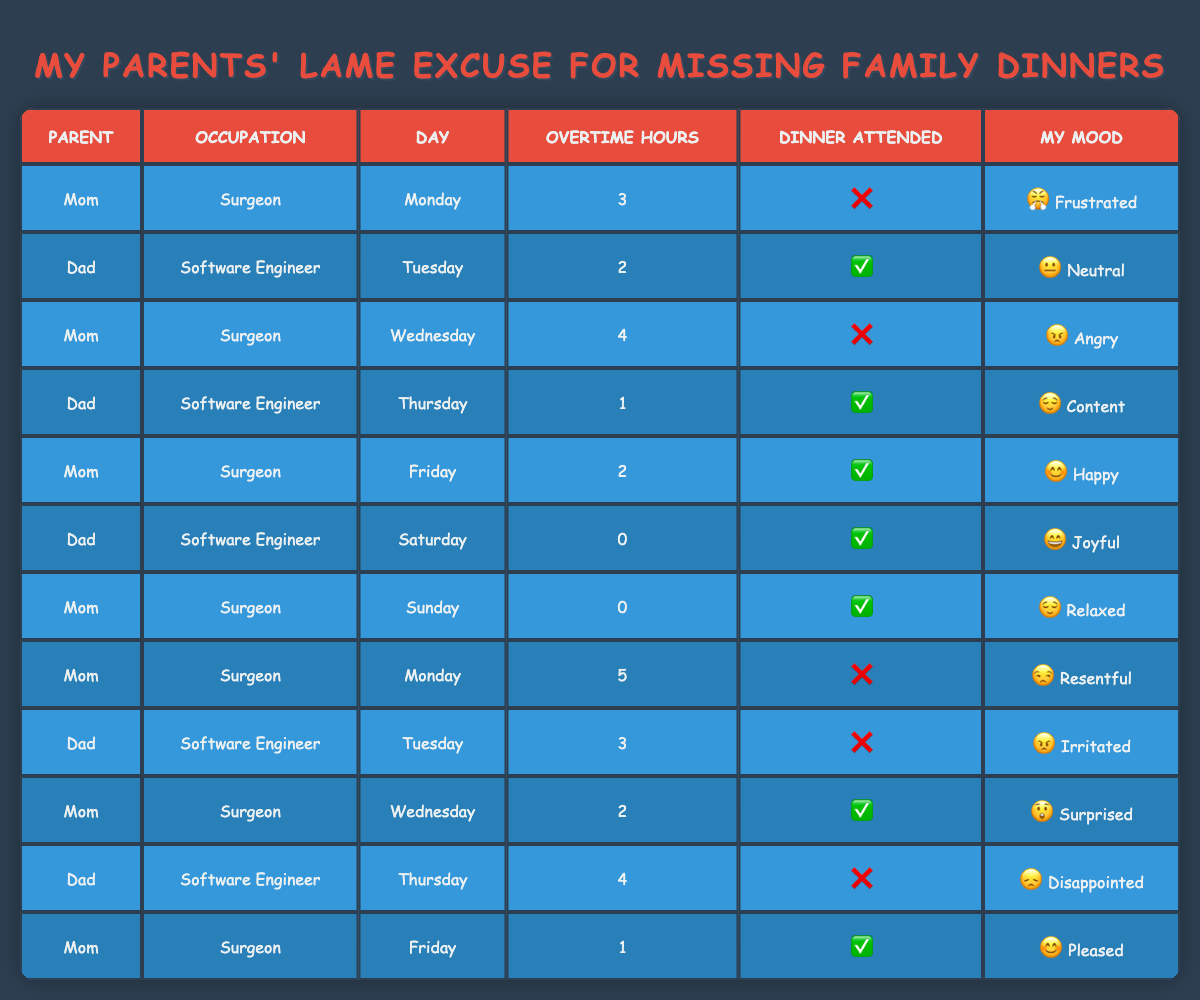What are the total overtime hours worked by Mom? Mom has worked overtime on multiple days: Monday (3 + 5), Wednesday (4 + 2), Friday (2 + 1), totaling 15 hours.
Answer: 15 How many family dinners did Dad attend? Dad attended family dinners on Tuesday, Thursday, Saturday, and Sunday, which accounts for 4 dinners.
Answer: 4 What was Mom's mood on the day she worked the most overtime? Mom worked the most overtime (5 hours) on Monday and her mood was resentful.
Answer: Resentful Did Dad attend dinner on the day he worked the least number of overtime hours? On Saturday, Dad worked 0 overtime hours and attended dinner, so yes, he attended.
Answer: Yes What is the average number of overtime hours worked by each parent? Mom's overtime hours: 3, 4, 2, 5, 2 = 16 hours (5 days). Dad's overtime hours: 2, 1, 0, 3, 4 = 10 hours (5 days). Mom's average is 16/5 = 3.2, Dad's average is 10/5 = 2.
Answer: Mom: 3.2, Dad: 2 Which day had the highest total overtime hours worked? The highest total is on Wednesday, with Mom working 4 hours and Dad not working (0 hours), giving a total of 4 hours.
Answer: 4 How many dinners did Mom attend while being in a happy or content mood? Mom attended two dinners while in a happy mood (Friday) and an unrelated mood of contentment (Wednesday, Dad’s mood). So, Mom attended one dinner when happy.
Answer: 1 What is the total number of family dinners missed due to overtime by both parents? Mom missed dinners 4 times (Monday, Wednesday, another Monday) and Dad missed twice (Tuesday, Thursday). Therefore, 4 + 2 = 6.
Answer: 6 Was there any day when both parents attended the family dinner? Yes, both attended dinner on Friday (Mom) and Saturday (Dad).
Answer: Yes 